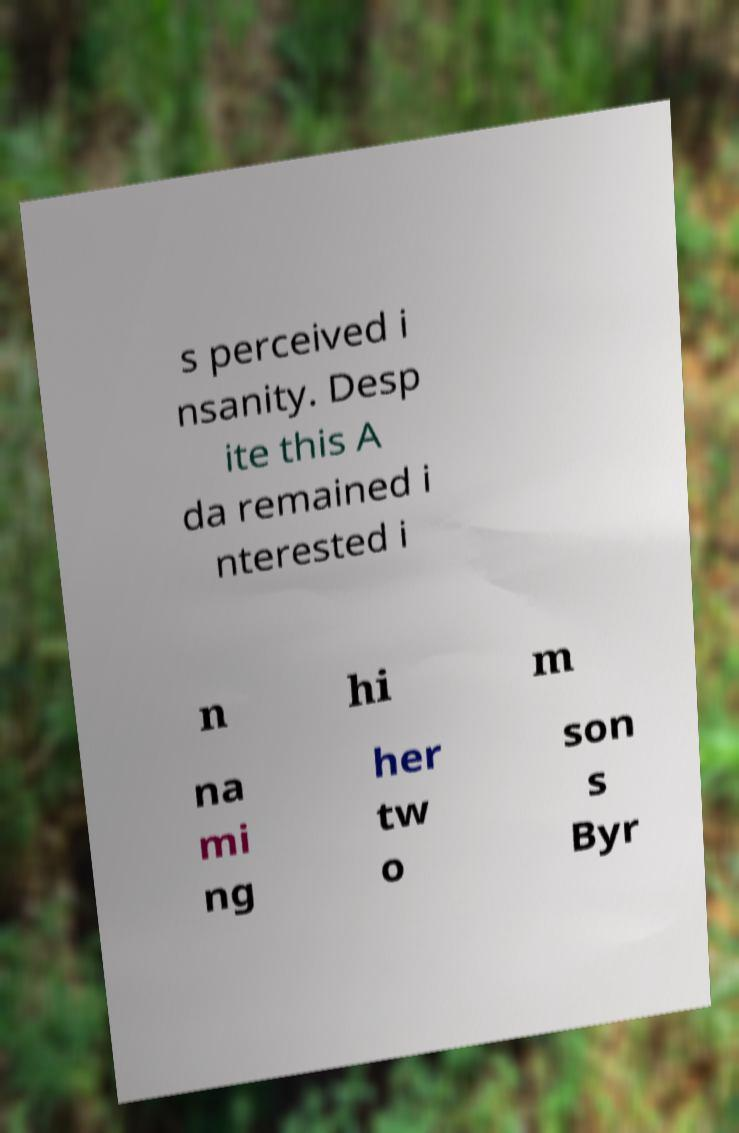Please read and relay the text visible in this image. What does it say? s perceived i nsanity. Desp ite this A da remained i nterested i n hi m na mi ng her tw o son s Byr 